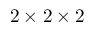<formula> <loc_0><loc_0><loc_500><loc_500>2 \times 2 \times 2</formula> 